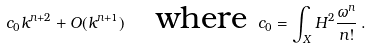<formula> <loc_0><loc_0><loc_500><loc_500>c _ { 0 } k ^ { n + 2 } + O ( k ^ { n + 1 } ) \quad \text {where} \ c _ { 0 } = \int _ { X } H ^ { 2 } \frac { \omega ^ { n } } { n ! } \, .</formula> 